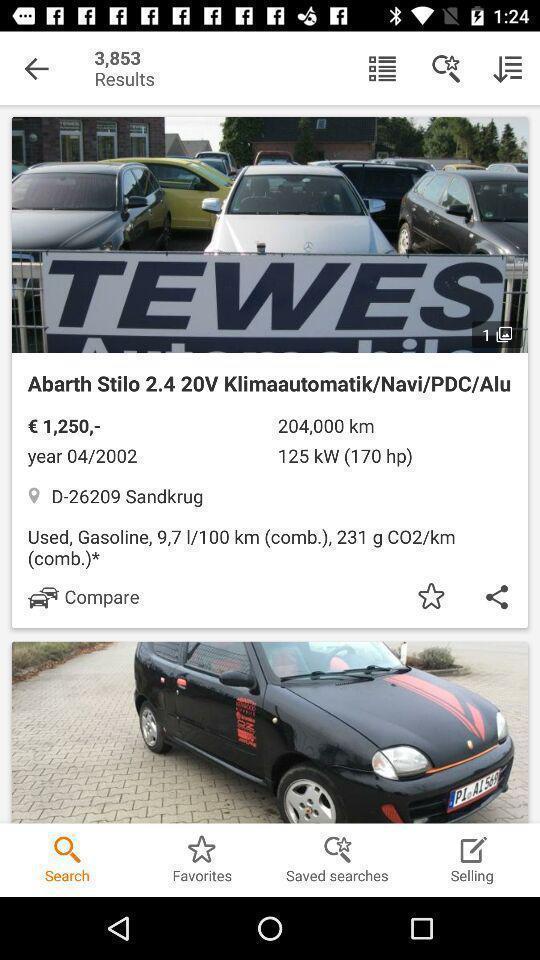Tell me what you see in this picture. Search bar of an automobile app with cars details. 